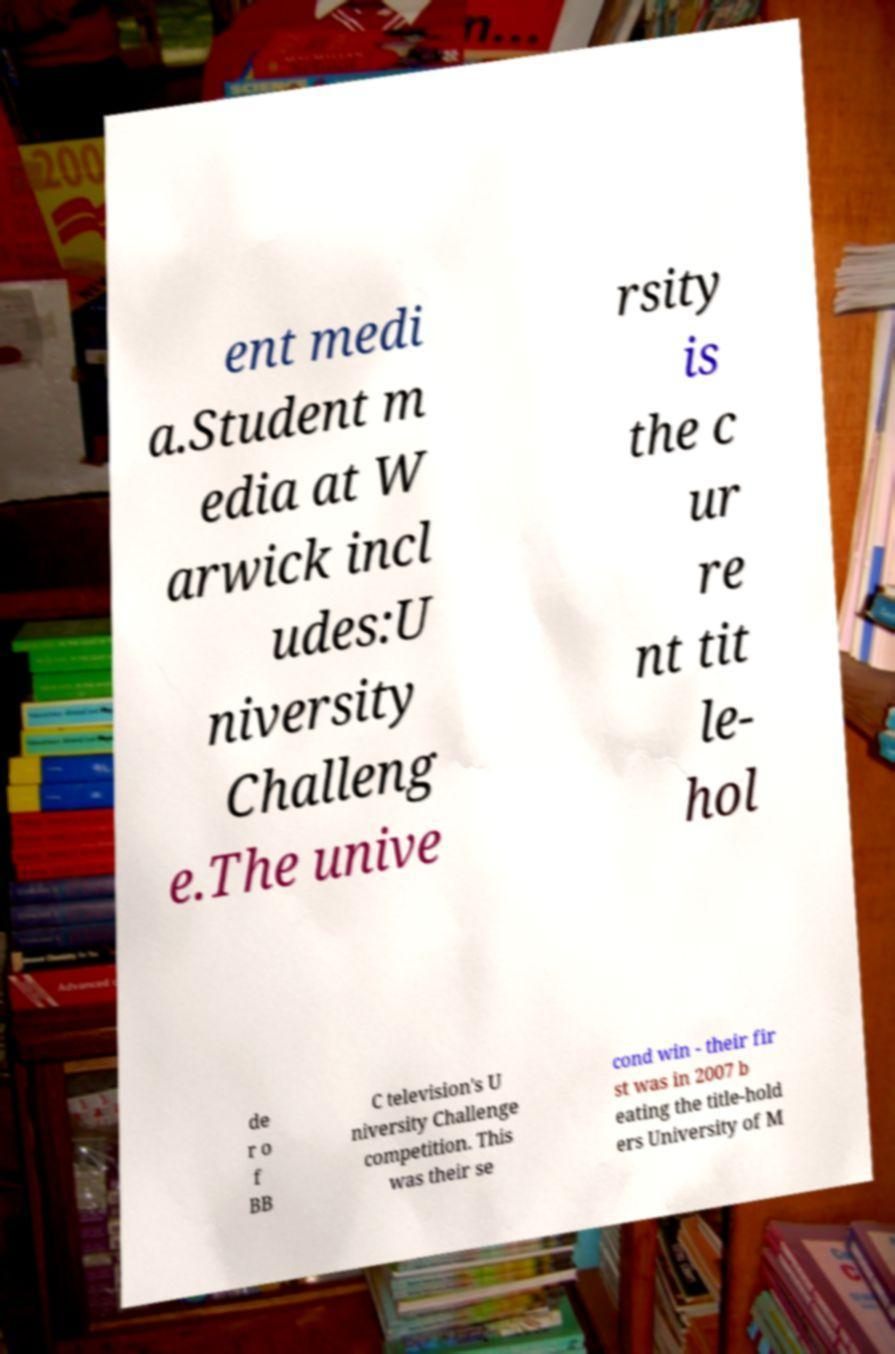Please identify and transcribe the text found in this image. ent medi a.Student m edia at W arwick incl udes:U niversity Challeng e.The unive rsity is the c ur re nt tit le- hol de r o f BB C television's U niversity Challenge competition. This was their se cond win - their fir st was in 2007 b eating the title-hold ers University of M 